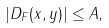<formula> <loc_0><loc_0><loc_500><loc_500>| D _ { F } ( x , y ) | \leq A ,</formula> 